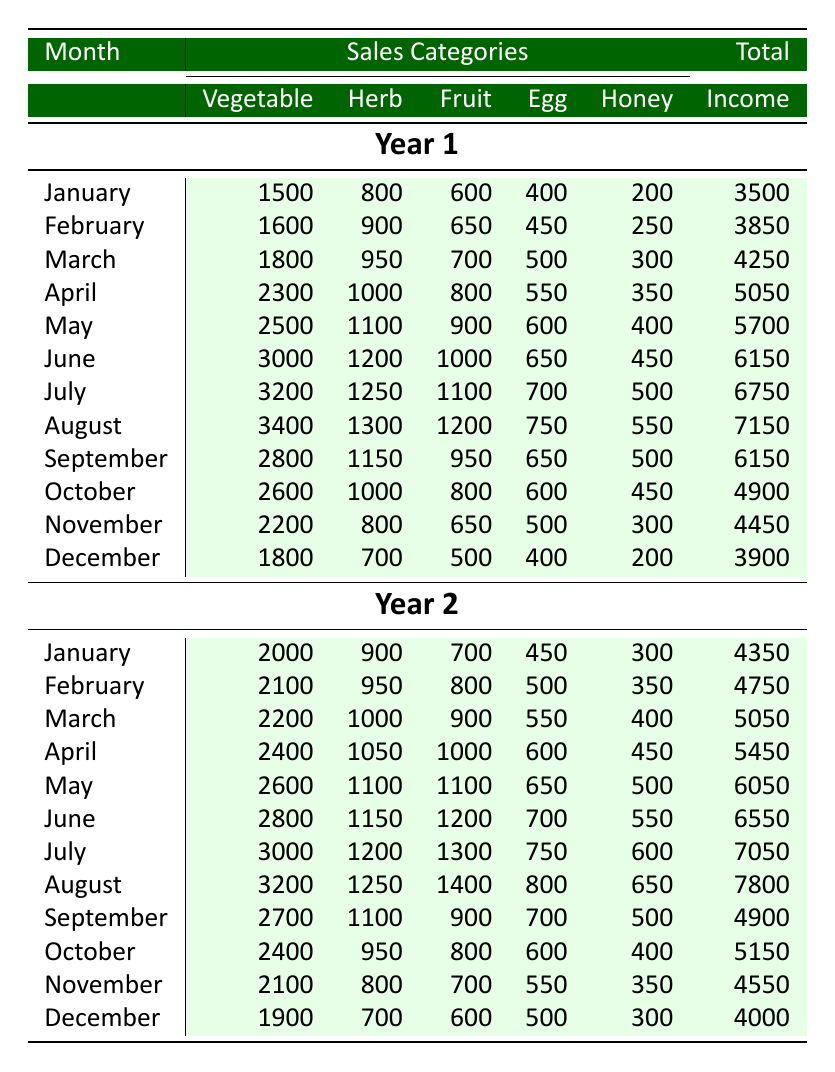What was the total income for June in Year 1? Looking at the table, we can find the row for June under Year 1. The total income listed there is 6150.
Answer: 6150 What was the highest earning month in Year 2? We need to review each month's total income in Year 2. The highest total is found in August, which has an income of 7800.
Answer: 7800 Did the vegetable sales in Year 1 increase every month? By checking the vegetable sales for each month in Year 1, we see that the sales increased from January to August but showed a decline in September and then dropped further in October, November, and December. Hence, the statement is false.
Answer: No What was the average monthly income for Year 1? Sum all total incomes for Year 1: (3500 + 3850 + 4250 + 5050 + 5700 + 6150 + 6750 + 7150 + 6150 + 4900 + 4450 + 3900 = 60700). There are 12 months, so the average is 60700 / 12 = 5058.33.
Answer: 5058.33 In which month of Year 1 did the herb sales exceed 1000? Review the herb sales for each month in Year 1. The herb sales exceeded 1000 starting in April, where it recorded 1000, and continued increasing.
Answer: April What is the total income difference between Year 1 and Year 2 for the month of May? For May in Year 1, the total income is 5700, and for May in Year 2, it is 6050. Calculating the difference gives us 6050 - 5700 = 350.
Answer: 350 Which month had less than 500 in egg sales during Year 2? By examining the row data for egg sales in Year 2, we find that the minimum egg sales recorded was 450 in January, which is the only month under 500.
Answer: January What was the total income for Year 1 and Year 2 combined? Summing the total incomes for both years separately: Year 1 total is 60700 and Year 2 total is (4350 + 4750 + 5050 + 5450 + 6050 + 6550 + 7050 + 7800 + 4900 + 5150 + 4550 + 4000 = 61900). The combined total is 60700 + 61900 = 122600.
Answer: 122600 What were the fruit sales in July of Year 2? Check the July row in Year 2 for fruit sales. It shows that the fruit sales amounted to 1300.
Answer: 1300 